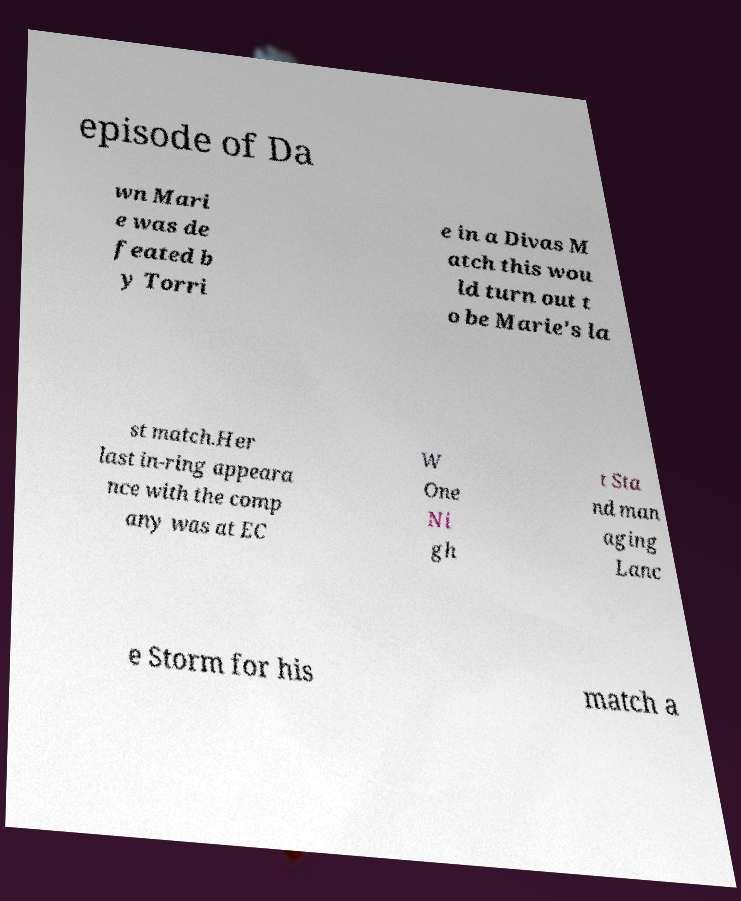Can you read and provide the text displayed in the image?This photo seems to have some interesting text. Can you extract and type it out for me? episode of Da wn Mari e was de feated b y Torri e in a Divas M atch this wou ld turn out t o be Marie's la st match.Her last in-ring appeara nce with the comp any was at EC W One Ni gh t Sta nd man aging Lanc e Storm for his match a 